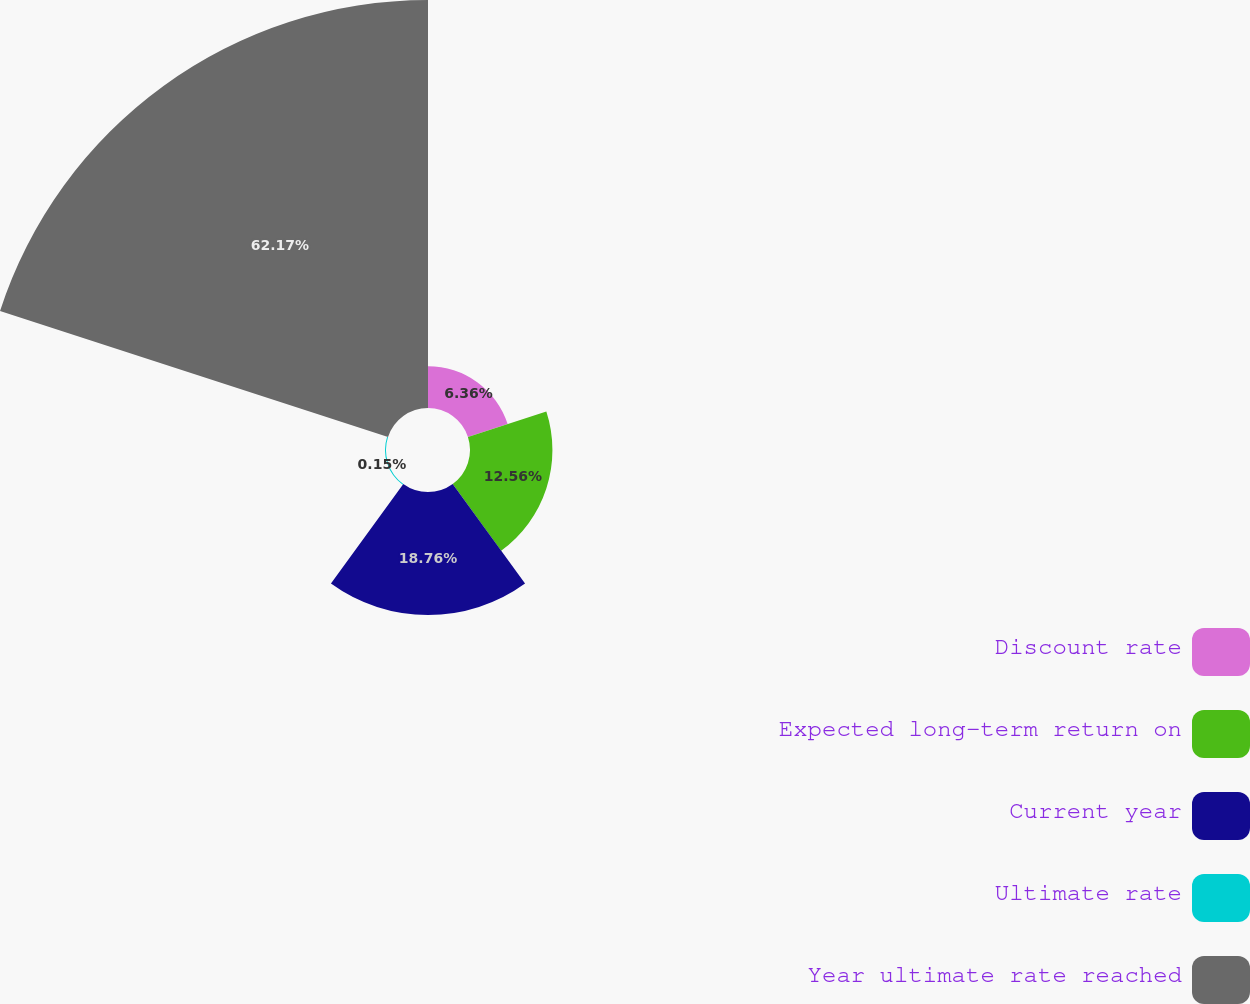Convert chart. <chart><loc_0><loc_0><loc_500><loc_500><pie_chart><fcel>Discount rate<fcel>Expected long-term return on<fcel>Current year<fcel>Ultimate rate<fcel>Year ultimate rate reached<nl><fcel>6.36%<fcel>12.56%<fcel>18.76%<fcel>0.15%<fcel>62.17%<nl></chart> 